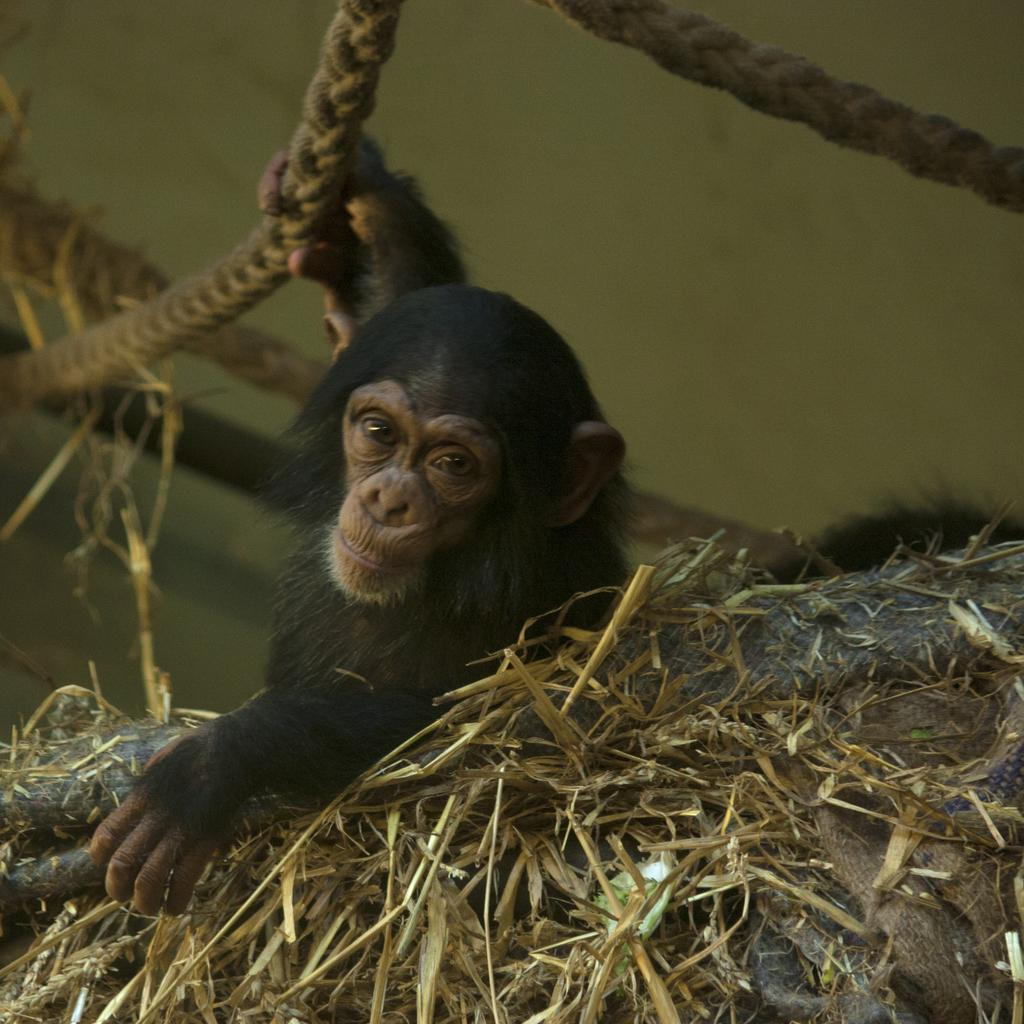What animal is present in the image? There is a chimpanzee in the image. What is the chimpanzee holding in the image? The chimpanzee is holding a rope. What type of vegetation can be seen in the image? There is dry grass in the image. Can you see a snake slithering through the dry grass in the image? There is no snake present in the image; it only features a chimpanzee holding a rope and dry grass. Is there a squirrel climbing the mountain in the image? There is no mountain or squirrel present in the image. 